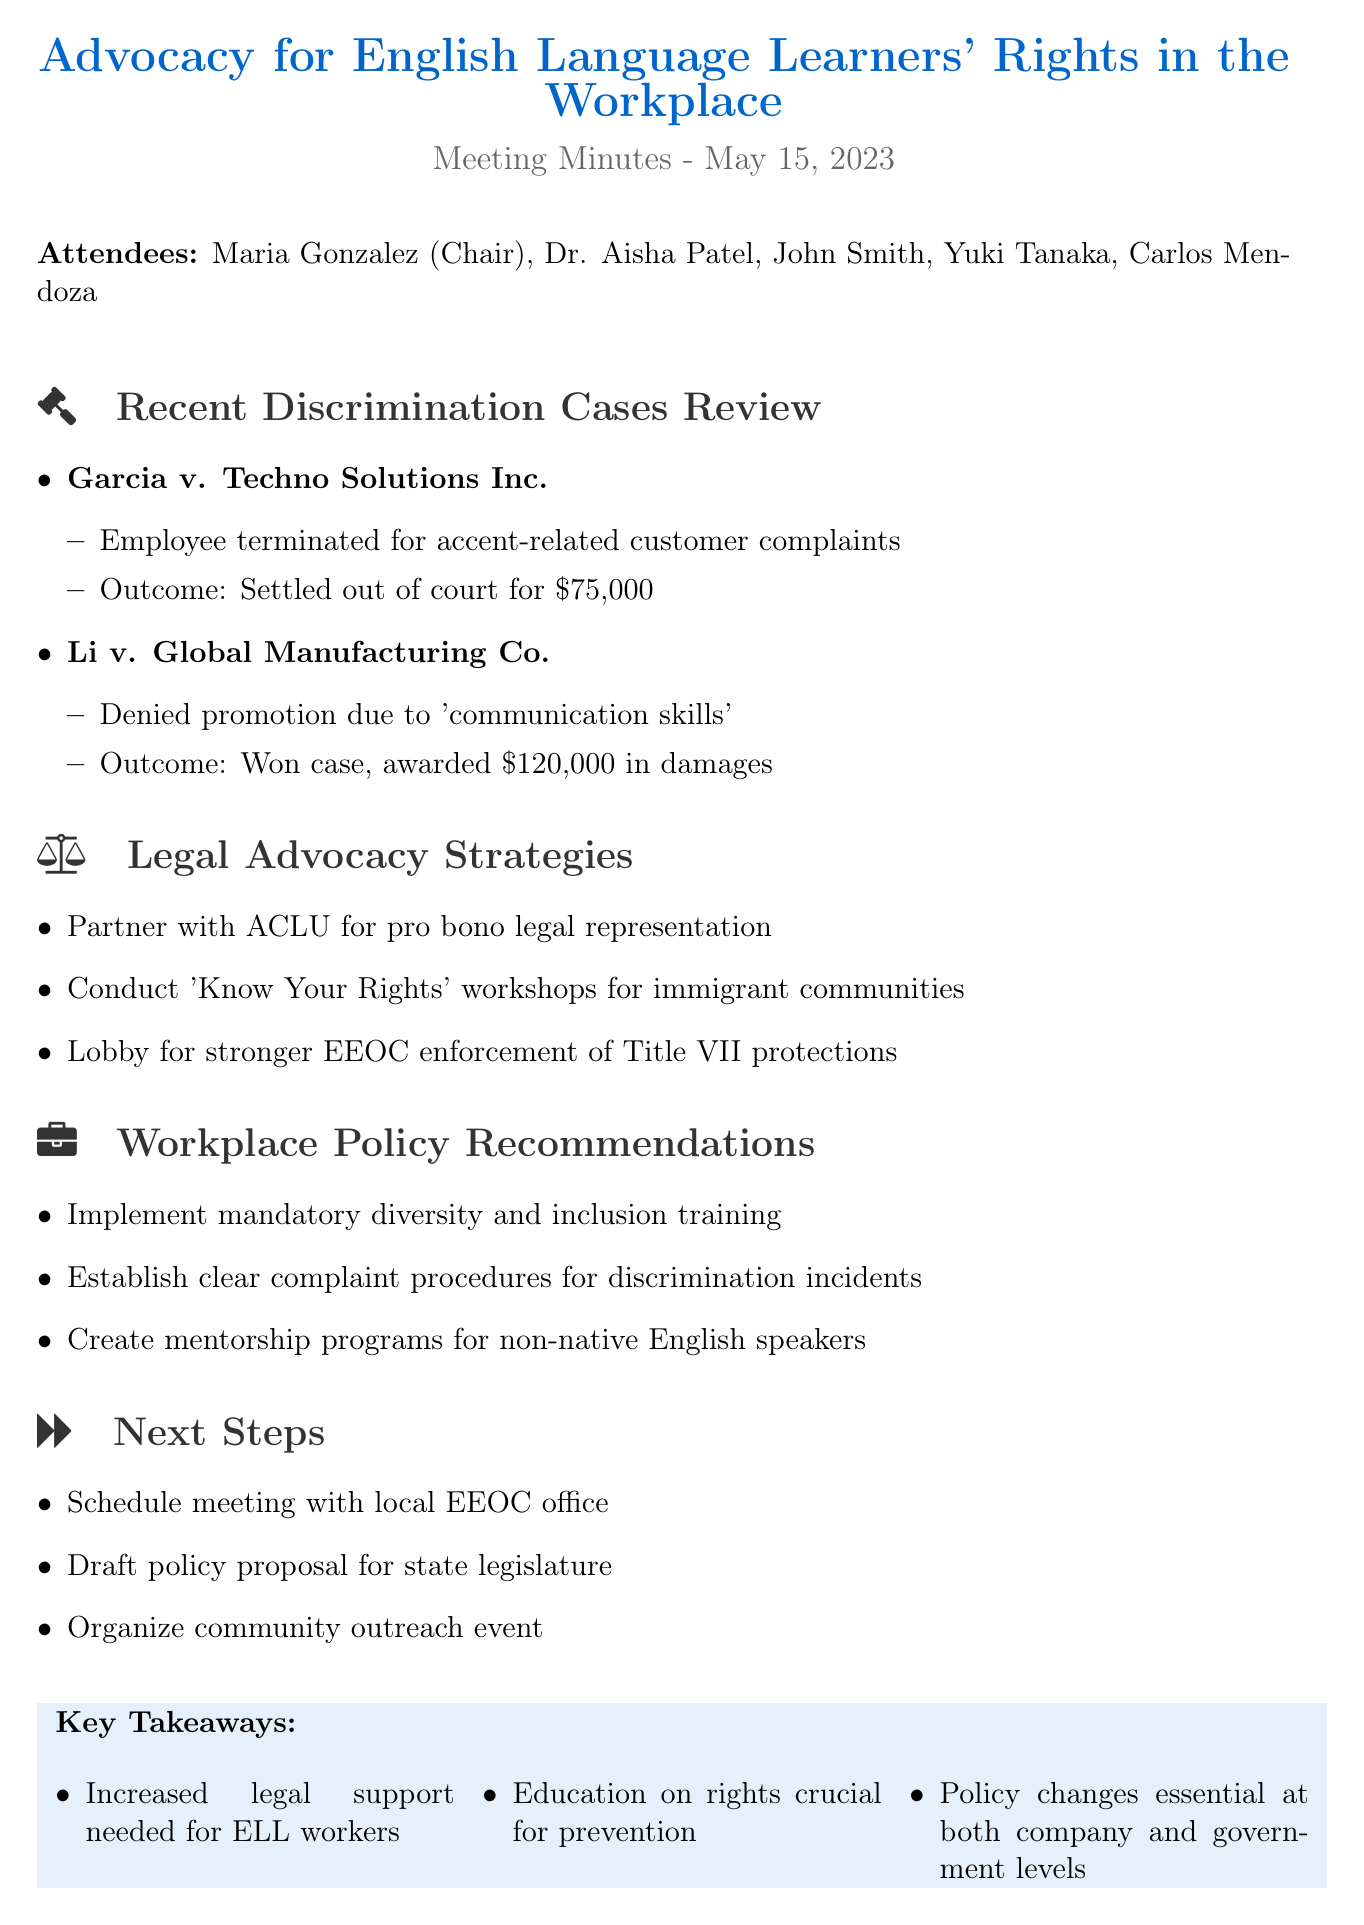What is the title of the meeting? The title of the meeting is the main heading at the top of the document.
Answer: Advocacy for English Language Learners' Rights in the Workplace Who chaired the meeting? The chairperson is mentioned alongside the list of attendees.
Answer: Maria Gonzalez What was the outcome of Garcia v. Techno Solutions Inc.? The outcome is noted in the discrimination cases review section under the specific case heading.
Answer: Settled out of court for $75,000 How much was awarded in Li v. Global Manufacturing Co.? The award amount is specified in the summary of the case outcome section.
Answer: $120,000 Which organization will be partnered with for legal representation? The partnership organization is listed in the legal advocacy strategies section.
Answer: ACLU What is one of the workplace policy recommendations? The recommendations are categorized in their own section and focus on specific actions.
Answer: Implement mandatory diversity and inclusion training What are the key takeaways from the meeting? The key takeaways are summarized at the end of the document.
Answer: Increased legal support needed for ELL workers How many actions are listed in the Next Steps section? The number of actions is determined by simply counting them in that section.
Answer: 3 What date was the meeting held? The meeting date is indicated prominently under the meeting title.
Answer: May 15, 2023 